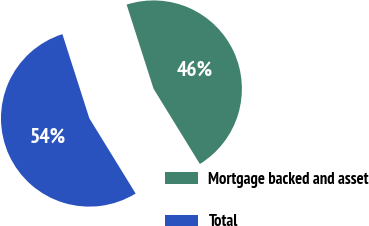Convert chart. <chart><loc_0><loc_0><loc_500><loc_500><pie_chart><fcel>Mortgage backed and asset<fcel>Total<nl><fcel>46.15%<fcel>53.85%<nl></chart> 